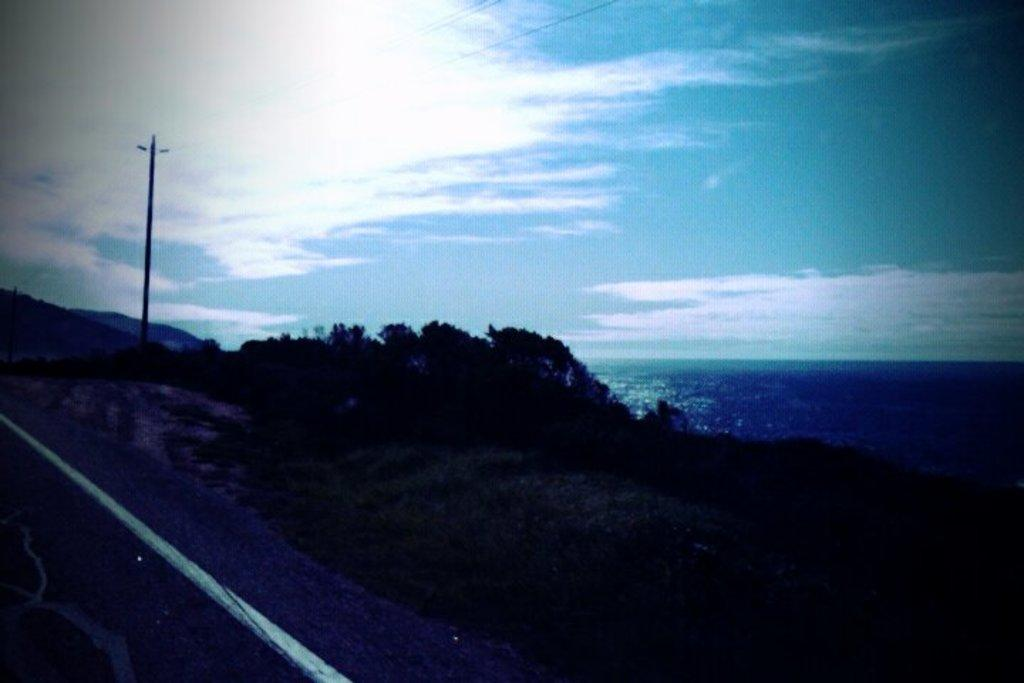What is located in the middle of the image? There are trees and poles in the middle of the image. What can be seen behind the trees in the image? There is water visible behind the trees. What is visible in the sky in the image? There are clouds in the sky, and the sky is visible at the top of the image. How many feet are visible in the image? There are no feet present in the image. Is there a tent visible in the image? There is no tent present in the image. 